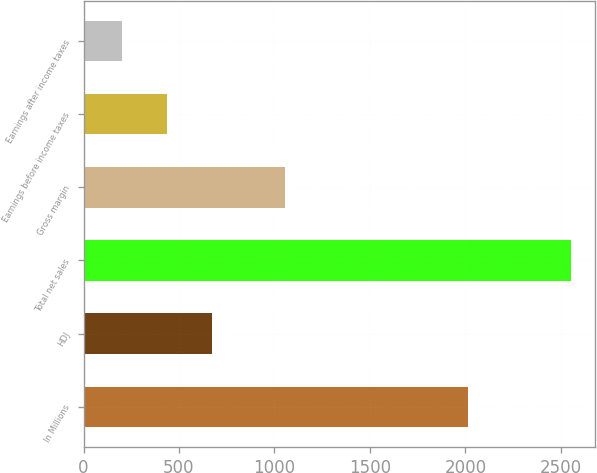<chart> <loc_0><loc_0><loc_500><loc_500><bar_chart><fcel>In Millions<fcel>HDJ<fcel>Total net sales<fcel>Gross margin<fcel>Earnings before income taxes<fcel>Earnings after income taxes<nl><fcel>2013<fcel>671.82<fcel>2552.7<fcel>1057.3<fcel>436.71<fcel>201.6<nl></chart> 